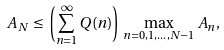Convert formula to latex. <formula><loc_0><loc_0><loc_500><loc_500>A _ { N } \, \leq \, \left ( \sum _ { n = 1 } ^ { \infty } Q ( n ) \right ) \, \max _ { n = 0 , 1 , \dots , N - 1 } A _ { n } ,</formula> 